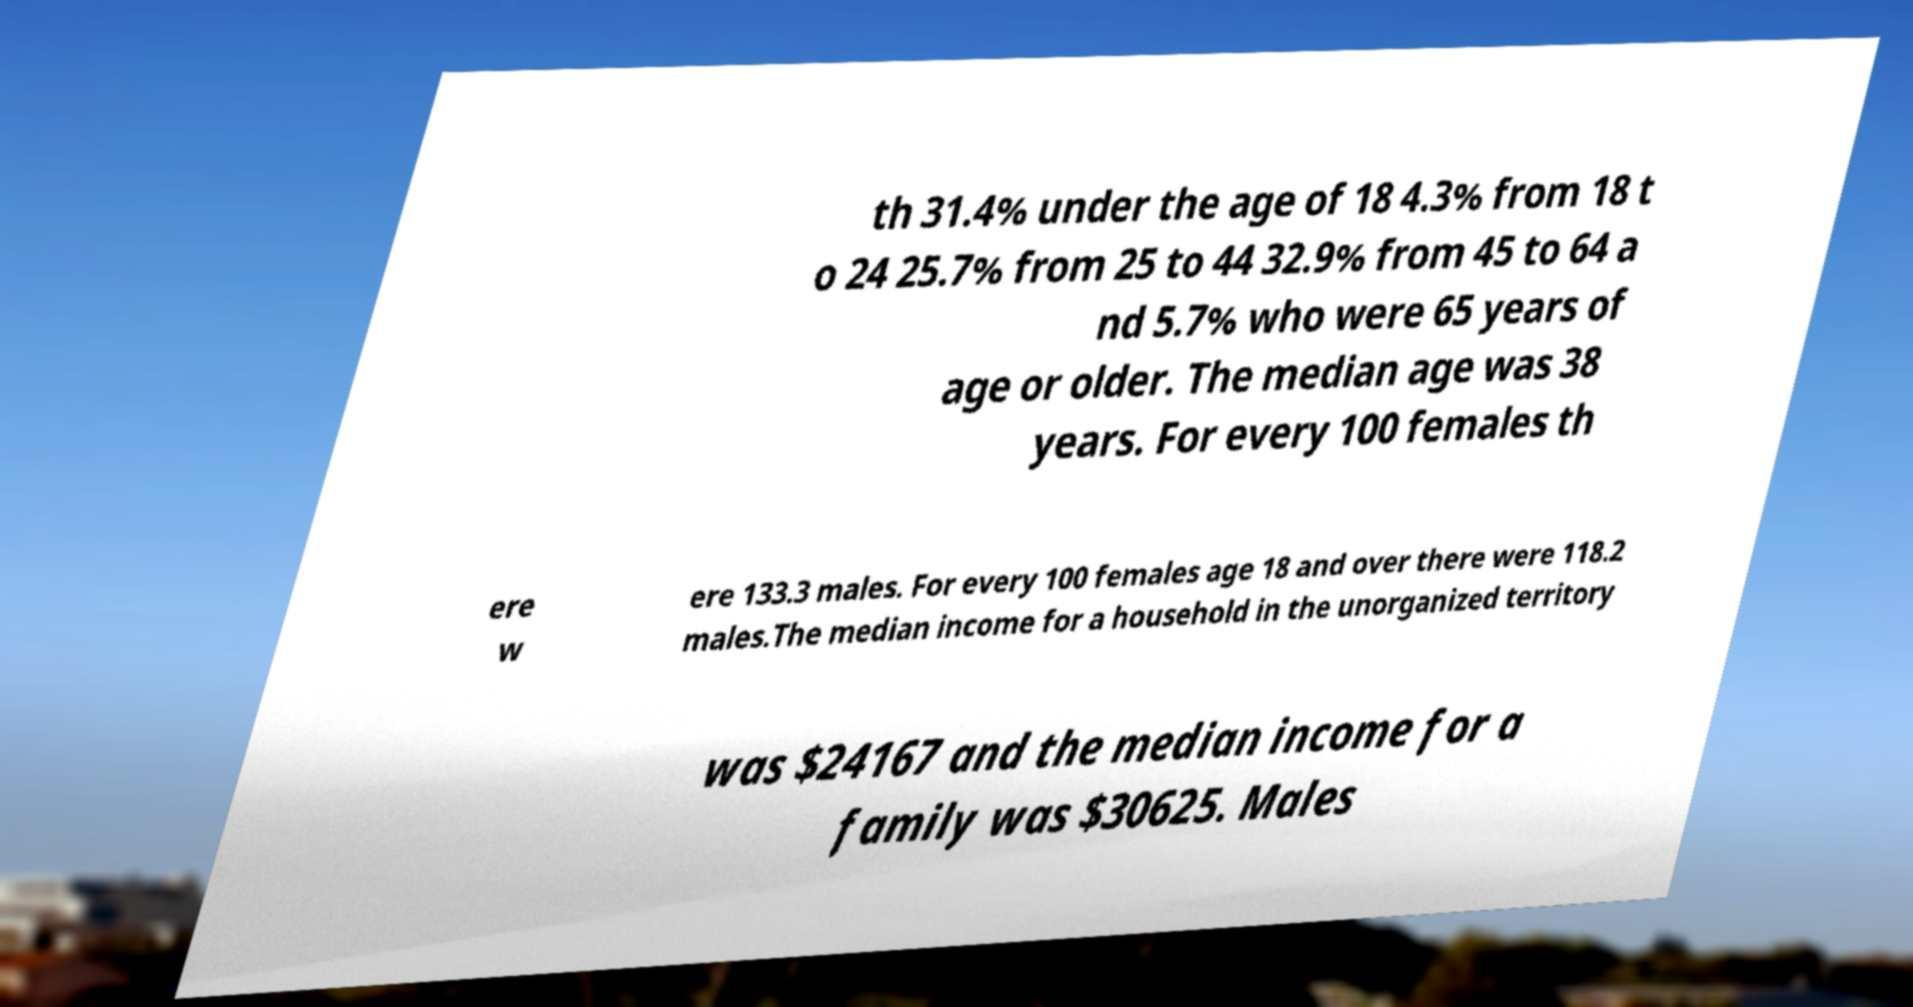Can you accurately transcribe the text from the provided image for me? th 31.4% under the age of 18 4.3% from 18 t o 24 25.7% from 25 to 44 32.9% from 45 to 64 a nd 5.7% who were 65 years of age or older. The median age was 38 years. For every 100 females th ere w ere 133.3 males. For every 100 females age 18 and over there were 118.2 males.The median income for a household in the unorganized territory was $24167 and the median income for a family was $30625. Males 